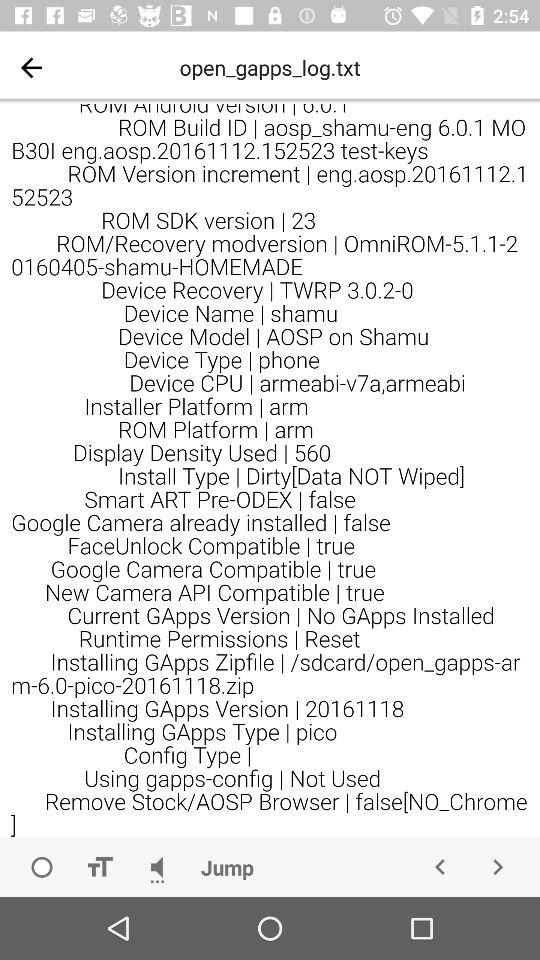What is the "Installing GApps Version"? The "Installing GApps Version" is 20161118. 